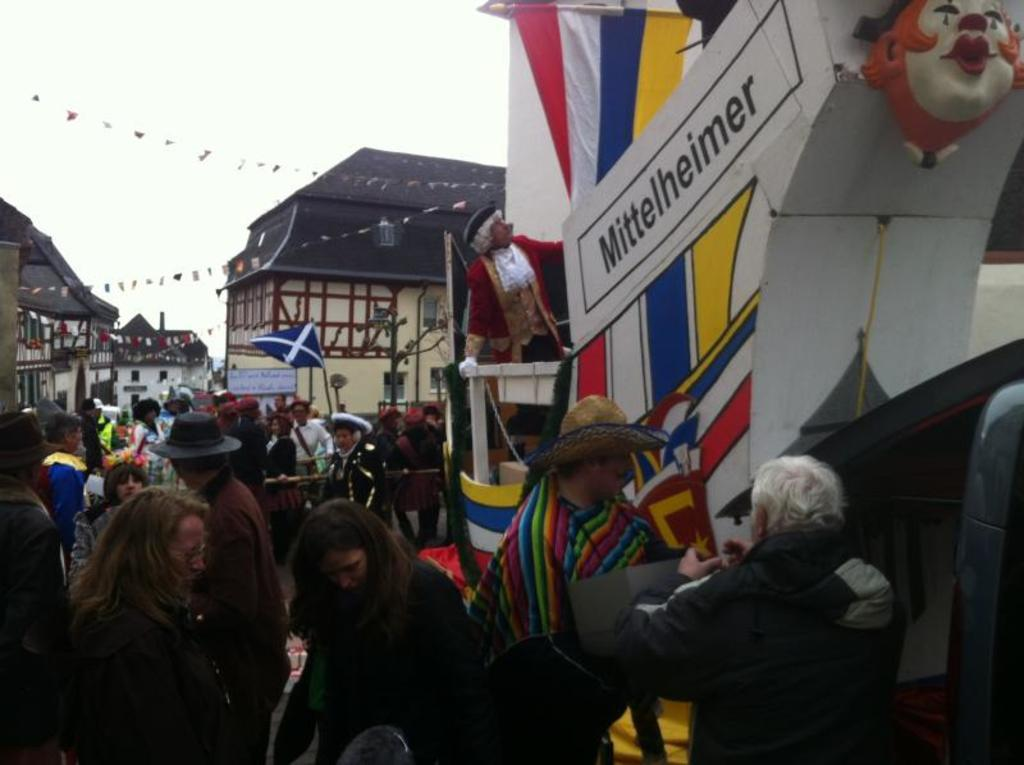What can be seen on the left side of the image? There are people and houses on the left side of the image. Can you describe the people in the image? The provided facts do not give any information about the people's appearance or actions. How many houses are visible on the left side of the image? The provided facts do not specify the number of houses. How many pigs are present in the image? There is no mention of pigs in the provided facts, so we cannot determine their presence or number in the image. Who is the creator of the image? The provided facts do not give any information about the creator of the image. 